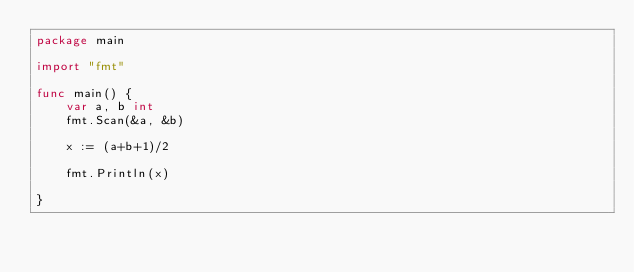<code> <loc_0><loc_0><loc_500><loc_500><_Go_>package main

import "fmt"

func main() {
	var a, b int
	fmt.Scan(&a, &b)

	x := (a+b+1)/2

	fmt.Println(x)

}
</code> 